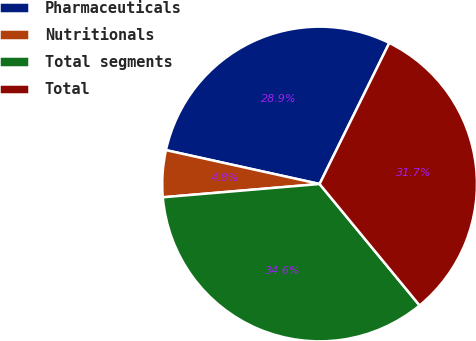<chart> <loc_0><loc_0><loc_500><loc_500><pie_chart><fcel>Pharmaceuticals<fcel>Nutritionals<fcel>Total segments<fcel>Total<nl><fcel>28.85%<fcel>4.8%<fcel>34.62%<fcel>31.73%<nl></chart> 